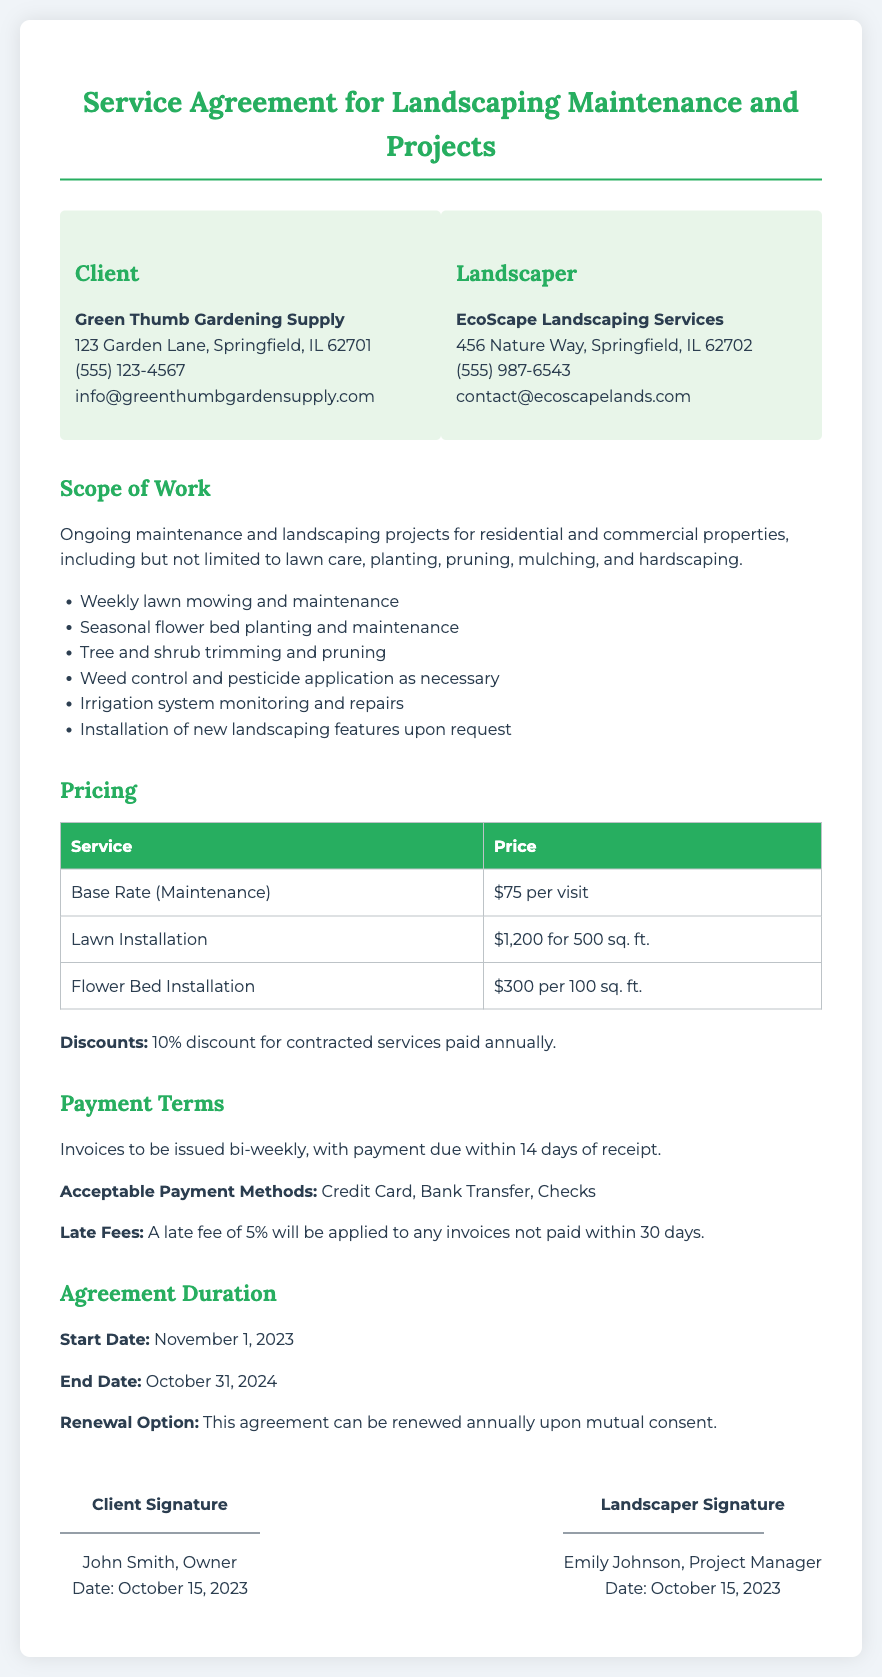What is the name of the client? The name of the client is listed in the document, specifically in the parties section, which states "Green Thumb Gardening Supply."
Answer: Green Thumb Gardening Supply Who is the project manager for EcoScape Landscaping Services? The document specifies the project manager in the signatures section as Emily Johnson.
Answer: Emily Johnson What is the price for lawn installation per 500 sq. ft.? The pricing table lists the cost for lawn installation as "$1,200 for 500 sq. ft."
Answer: $1,200 for 500 sq. ft What is the start date of the service agreement? The document clearly states the start date under the agreement duration section as November 1, 2023.
Answer: November 1, 2023 What is the late fee percentage for unpaid invoices? The late fee percentage is mentioned in the payment terms section as 5%.
Answer: 5% What services are included in the scope of work? The scope of work includes multiple services, such as lawn care and planting, mentioned in the description.
Answer: Ongoing maintenance and landscaping projects How often will invoices be issued? The payment terms section specifies that invoices will be issued bi-weekly.
Answer: Bi-weekly What is the client's phone number? The phone number of the client is provided in the contact details section as "(555) 123-4567."
Answer: (555) 123-4567 What discount is offered for annual payments? The pricing section mentions a 10% discount for contracted services paid annually.
Answer: 10% discount 